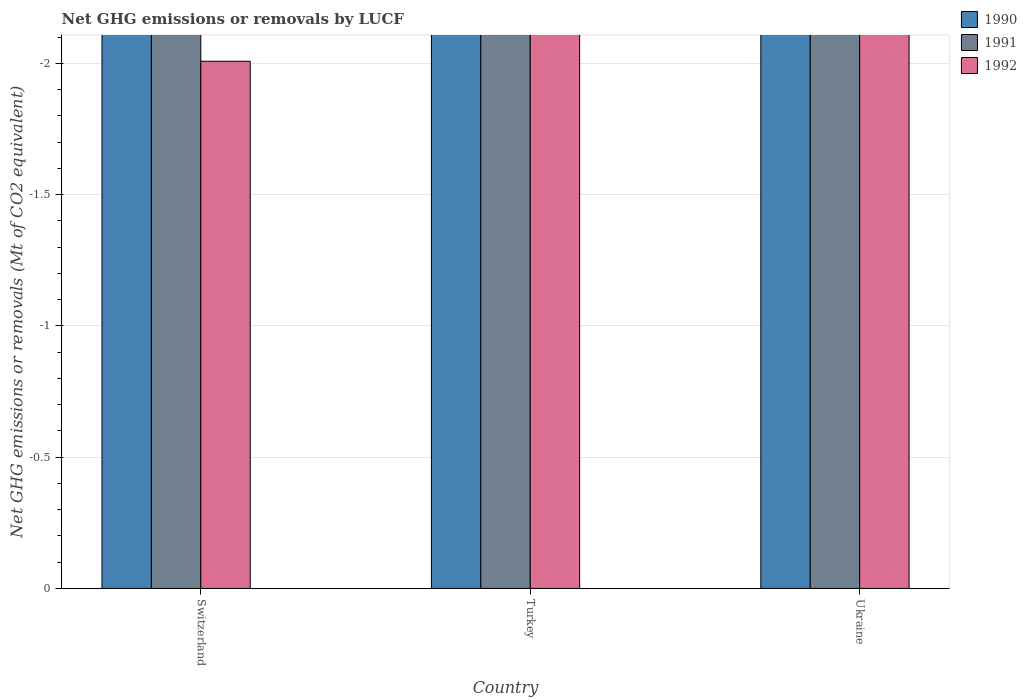How many bars are there on the 3rd tick from the left?
Keep it short and to the point. 0. How many bars are there on the 3rd tick from the right?
Ensure brevity in your answer.  0. What is the label of the 2nd group of bars from the left?
Keep it short and to the point. Turkey. What is the average net GHG emissions or removals by LUCF in 1992 per country?
Your answer should be very brief. 0. In how many countries, is the net GHG emissions or removals by LUCF in 1990 greater than the average net GHG emissions or removals by LUCF in 1990 taken over all countries?
Ensure brevity in your answer.  0. Is it the case that in every country, the sum of the net GHG emissions or removals by LUCF in 1991 and net GHG emissions or removals by LUCF in 1990 is greater than the net GHG emissions or removals by LUCF in 1992?
Provide a succinct answer. No. How many bars are there?
Offer a very short reply. 0. How many countries are there in the graph?
Provide a short and direct response. 3. Does the graph contain grids?
Provide a succinct answer. Yes. Where does the legend appear in the graph?
Keep it short and to the point. Top right. How many legend labels are there?
Your answer should be compact. 3. What is the title of the graph?
Your answer should be very brief. Net GHG emissions or removals by LUCF. What is the label or title of the X-axis?
Give a very brief answer. Country. What is the label or title of the Y-axis?
Provide a succinct answer. Net GHG emissions or removals (Mt of CO2 equivalent). What is the Net GHG emissions or removals (Mt of CO2 equivalent) of 1990 in Switzerland?
Offer a very short reply. 0. What is the Net GHG emissions or removals (Mt of CO2 equivalent) in 1992 in Switzerland?
Provide a short and direct response. 0. What is the Net GHG emissions or removals (Mt of CO2 equivalent) in 1991 in Ukraine?
Your response must be concise. 0. What is the total Net GHG emissions or removals (Mt of CO2 equivalent) in 1991 in the graph?
Give a very brief answer. 0. What is the average Net GHG emissions or removals (Mt of CO2 equivalent) in 1992 per country?
Your answer should be very brief. 0. 